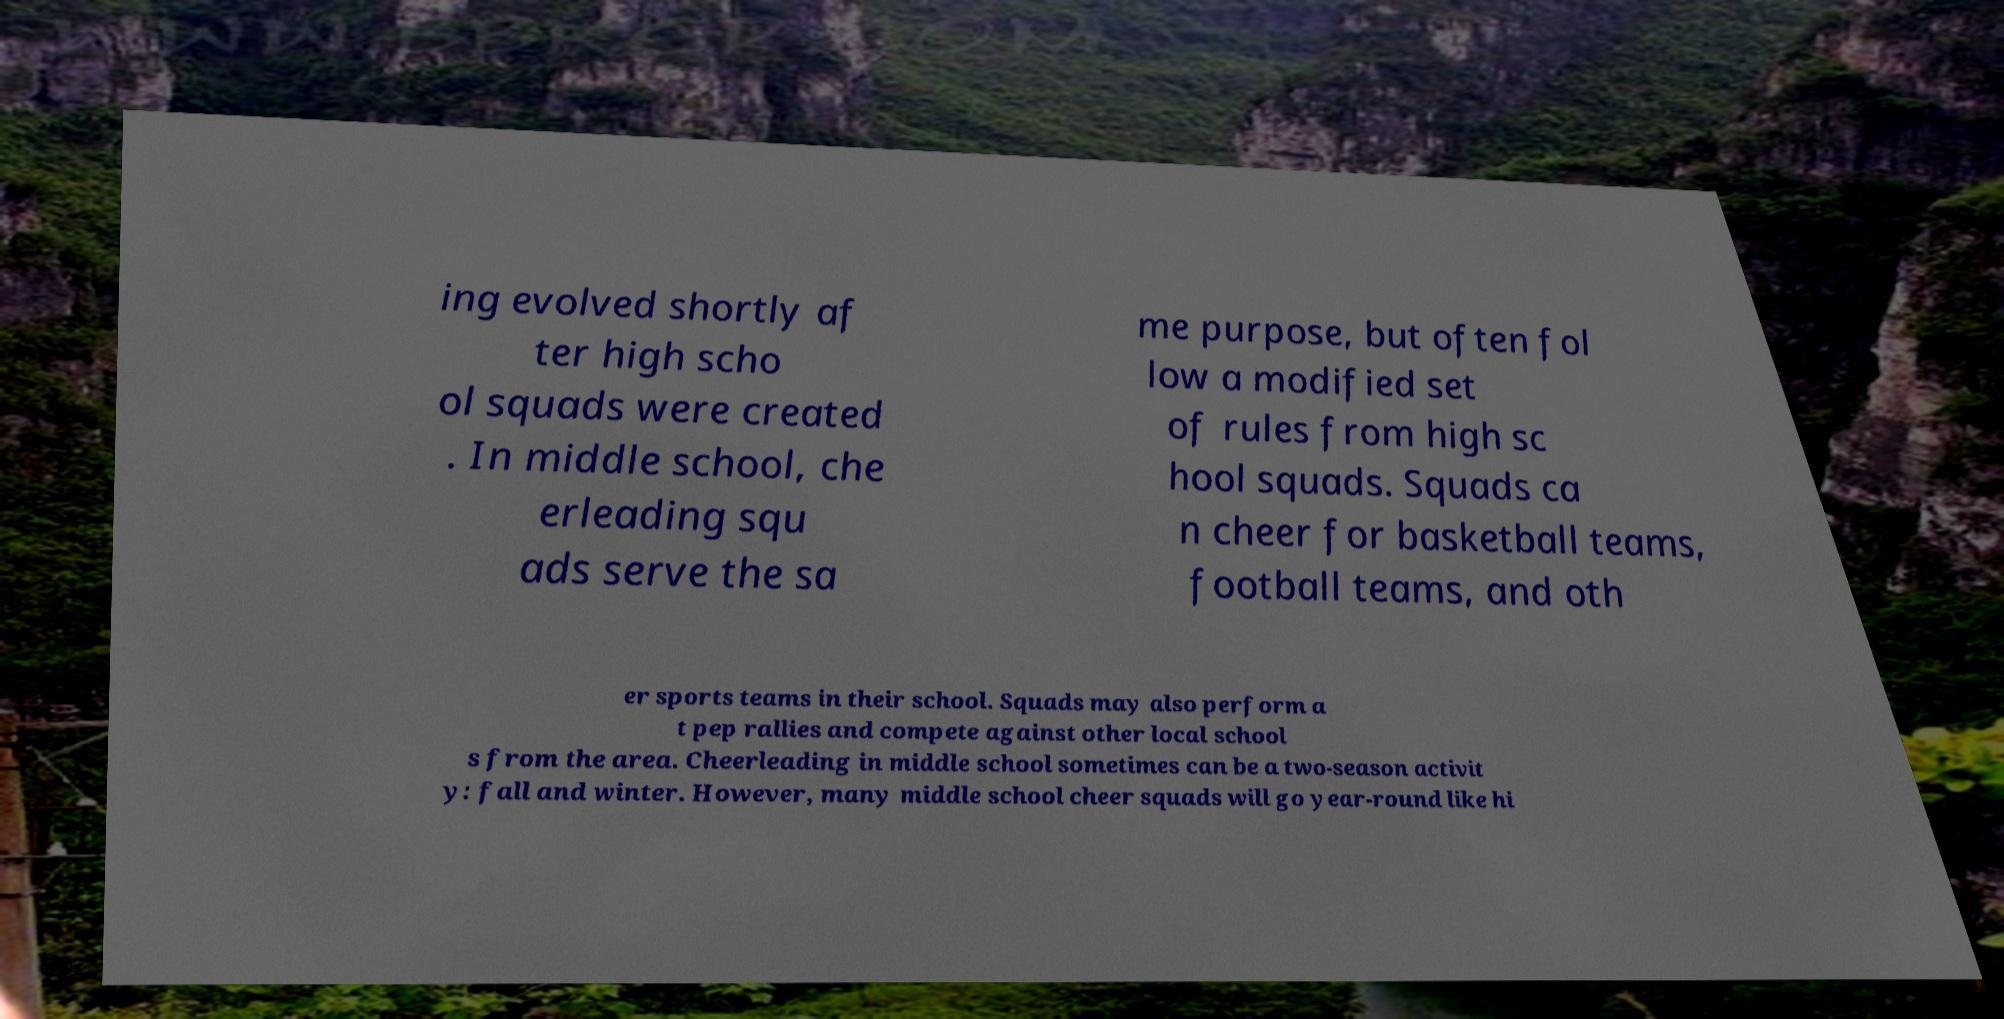For documentation purposes, I need the text within this image transcribed. Could you provide that? ing evolved shortly af ter high scho ol squads were created . In middle school, che erleading squ ads serve the sa me purpose, but often fol low a modified set of rules from high sc hool squads. Squads ca n cheer for basketball teams, football teams, and oth er sports teams in their school. Squads may also perform a t pep rallies and compete against other local school s from the area. Cheerleading in middle school sometimes can be a two-season activit y: fall and winter. However, many middle school cheer squads will go year-round like hi 